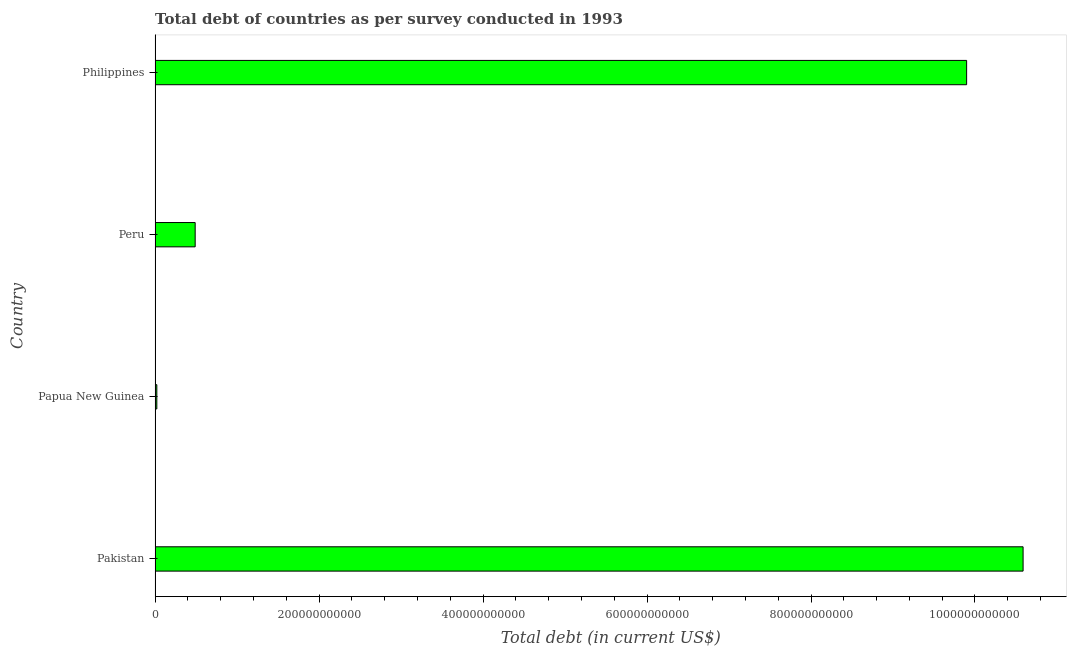What is the title of the graph?
Give a very brief answer. Total debt of countries as per survey conducted in 1993. What is the label or title of the X-axis?
Ensure brevity in your answer.  Total debt (in current US$). What is the total debt in Papua New Guinea?
Your answer should be compact. 2.16e+09. Across all countries, what is the maximum total debt?
Ensure brevity in your answer.  1.06e+12. Across all countries, what is the minimum total debt?
Ensure brevity in your answer.  2.16e+09. In which country was the total debt maximum?
Provide a short and direct response. Pakistan. In which country was the total debt minimum?
Keep it short and to the point. Papua New Guinea. What is the sum of the total debt?
Ensure brevity in your answer.  2.10e+12. What is the difference between the total debt in Papua New Guinea and Philippines?
Your response must be concise. -9.88e+11. What is the average total debt per country?
Offer a very short reply. 5.25e+11. What is the median total debt?
Offer a terse response. 5.19e+11. What is the ratio of the total debt in Peru to that in Philippines?
Offer a very short reply. 0.05. Is the total debt in Peru less than that in Philippines?
Your answer should be very brief. Yes. Is the difference between the total debt in Pakistan and Peru greater than the difference between any two countries?
Your answer should be very brief. No. What is the difference between the highest and the second highest total debt?
Provide a short and direct response. 6.89e+1. What is the difference between the highest and the lowest total debt?
Your response must be concise. 1.06e+12. In how many countries, is the total debt greater than the average total debt taken over all countries?
Your answer should be compact. 2. How many countries are there in the graph?
Provide a short and direct response. 4. What is the difference between two consecutive major ticks on the X-axis?
Provide a short and direct response. 2.00e+11. Are the values on the major ticks of X-axis written in scientific E-notation?
Keep it short and to the point. No. What is the Total debt (in current US$) of Pakistan?
Offer a very short reply. 1.06e+12. What is the Total debt (in current US$) in Papua New Guinea?
Give a very brief answer. 2.16e+09. What is the Total debt (in current US$) of Peru?
Keep it short and to the point. 4.89e+1. What is the Total debt (in current US$) in Philippines?
Provide a short and direct response. 9.90e+11. What is the difference between the Total debt (in current US$) in Pakistan and Papua New Guinea?
Provide a succinct answer. 1.06e+12. What is the difference between the Total debt (in current US$) in Pakistan and Peru?
Your response must be concise. 1.01e+12. What is the difference between the Total debt (in current US$) in Pakistan and Philippines?
Your answer should be very brief. 6.89e+1. What is the difference between the Total debt (in current US$) in Papua New Guinea and Peru?
Ensure brevity in your answer.  -4.68e+1. What is the difference between the Total debt (in current US$) in Papua New Guinea and Philippines?
Provide a succinct answer. -9.88e+11. What is the difference between the Total debt (in current US$) in Peru and Philippines?
Your response must be concise. -9.41e+11. What is the ratio of the Total debt (in current US$) in Pakistan to that in Papua New Guinea?
Give a very brief answer. 490.72. What is the ratio of the Total debt (in current US$) in Pakistan to that in Peru?
Provide a short and direct response. 21.64. What is the ratio of the Total debt (in current US$) in Pakistan to that in Philippines?
Give a very brief answer. 1.07. What is the ratio of the Total debt (in current US$) in Papua New Guinea to that in Peru?
Make the answer very short. 0.04. What is the ratio of the Total debt (in current US$) in Papua New Guinea to that in Philippines?
Your answer should be very brief. 0. What is the ratio of the Total debt (in current US$) in Peru to that in Philippines?
Offer a terse response. 0.05. 